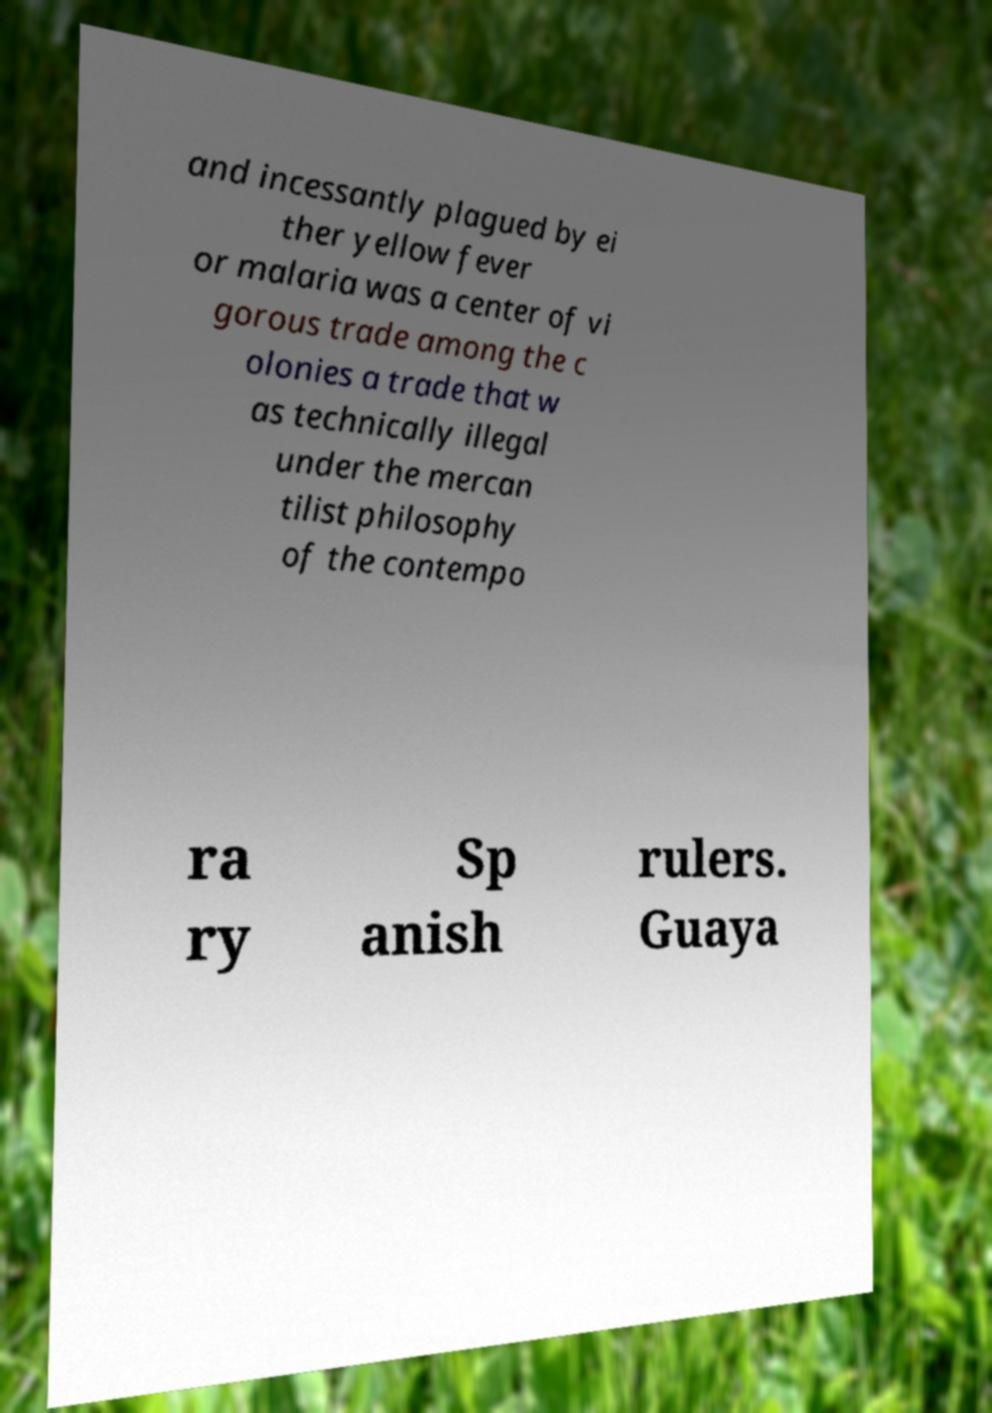For documentation purposes, I need the text within this image transcribed. Could you provide that? and incessantly plagued by ei ther yellow fever or malaria was a center of vi gorous trade among the c olonies a trade that w as technically illegal under the mercan tilist philosophy of the contempo ra ry Sp anish rulers. Guaya 